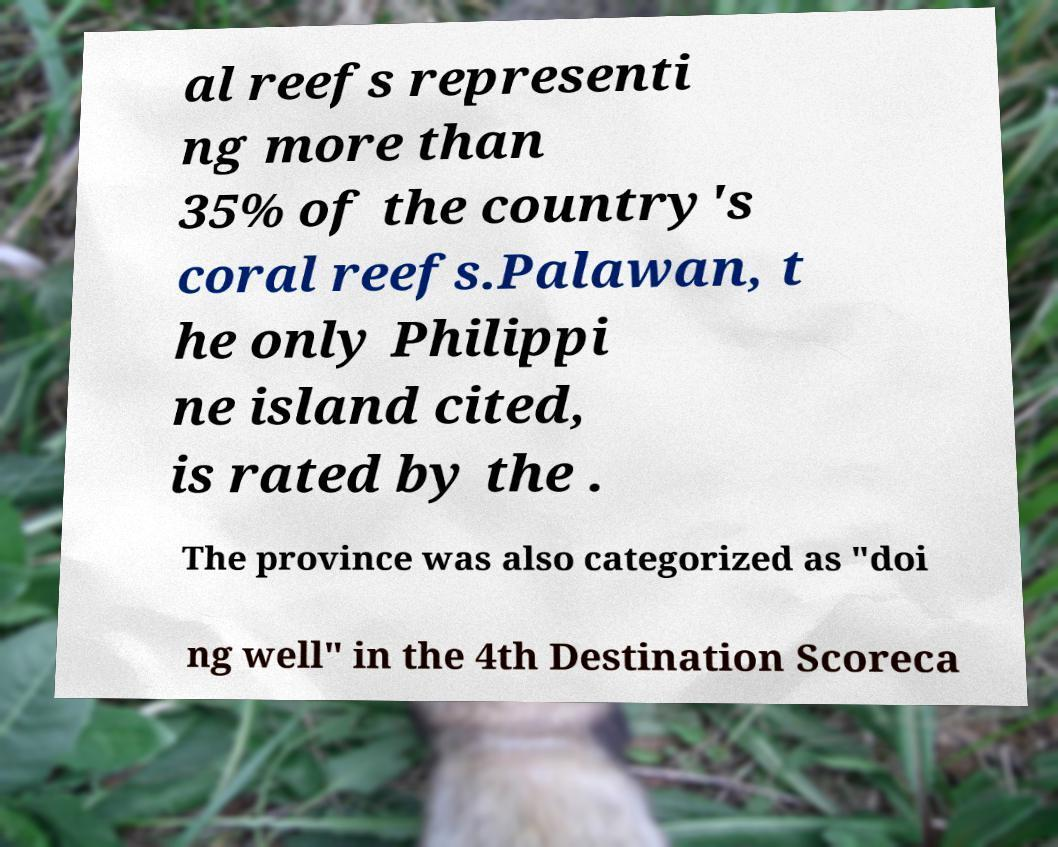There's text embedded in this image that I need extracted. Can you transcribe it verbatim? al reefs representi ng more than 35% of the country's coral reefs.Palawan, t he only Philippi ne island cited, is rated by the . The province was also categorized as "doi ng well" in the 4th Destination Scoreca 